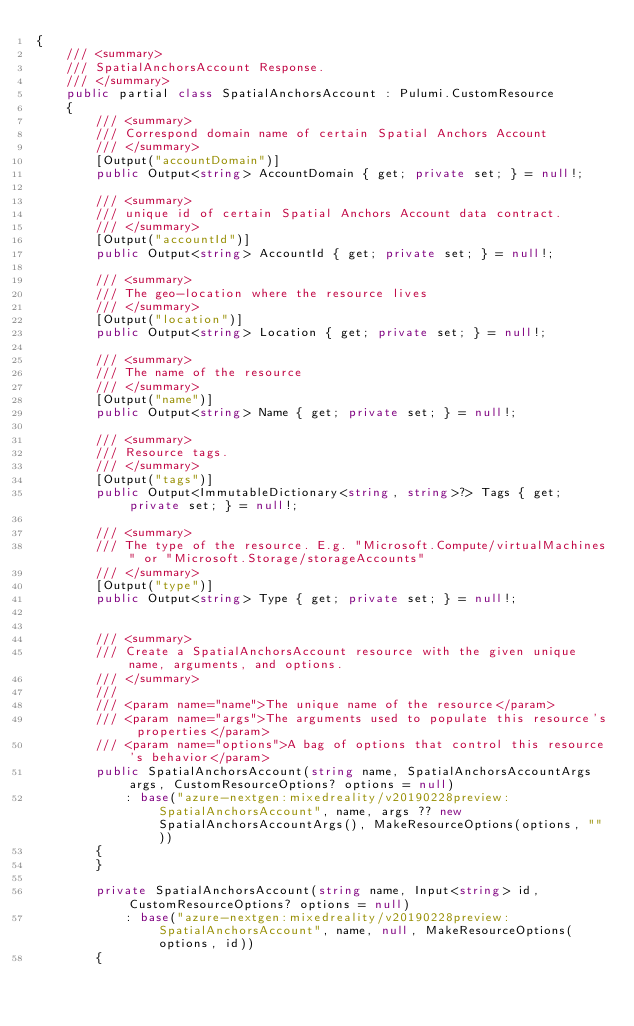<code> <loc_0><loc_0><loc_500><loc_500><_C#_>{
    /// <summary>
    /// SpatialAnchorsAccount Response.
    /// </summary>
    public partial class SpatialAnchorsAccount : Pulumi.CustomResource
    {
        /// <summary>
        /// Correspond domain name of certain Spatial Anchors Account
        /// </summary>
        [Output("accountDomain")]
        public Output<string> AccountDomain { get; private set; } = null!;

        /// <summary>
        /// unique id of certain Spatial Anchors Account data contract.
        /// </summary>
        [Output("accountId")]
        public Output<string> AccountId { get; private set; } = null!;

        /// <summary>
        /// The geo-location where the resource lives
        /// </summary>
        [Output("location")]
        public Output<string> Location { get; private set; } = null!;

        /// <summary>
        /// The name of the resource
        /// </summary>
        [Output("name")]
        public Output<string> Name { get; private set; } = null!;

        /// <summary>
        /// Resource tags.
        /// </summary>
        [Output("tags")]
        public Output<ImmutableDictionary<string, string>?> Tags { get; private set; } = null!;

        /// <summary>
        /// The type of the resource. E.g. "Microsoft.Compute/virtualMachines" or "Microsoft.Storage/storageAccounts"
        /// </summary>
        [Output("type")]
        public Output<string> Type { get; private set; } = null!;


        /// <summary>
        /// Create a SpatialAnchorsAccount resource with the given unique name, arguments, and options.
        /// </summary>
        ///
        /// <param name="name">The unique name of the resource</param>
        /// <param name="args">The arguments used to populate this resource's properties</param>
        /// <param name="options">A bag of options that control this resource's behavior</param>
        public SpatialAnchorsAccount(string name, SpatialAnchorsAccountArgs args, CustomResourceOptions? options = null)
            : base("azure-nextgen:mixedreality/v20190228preview:SpatialAnchorsAccount", name, args ?? new SpatialAnchorsAccountArgs(), MakeResourceOptions(options, ""))
        {
        }

        private SpatialAnchorsAccount(string name, Input<string> id, CustomResourceOptions? options = null)
            : base("azure-nextgen:mixedreality/v20190228preview:SpatialAnchorsAccount", name, null, MakeResourceOptions(options, id))
        {</code> 